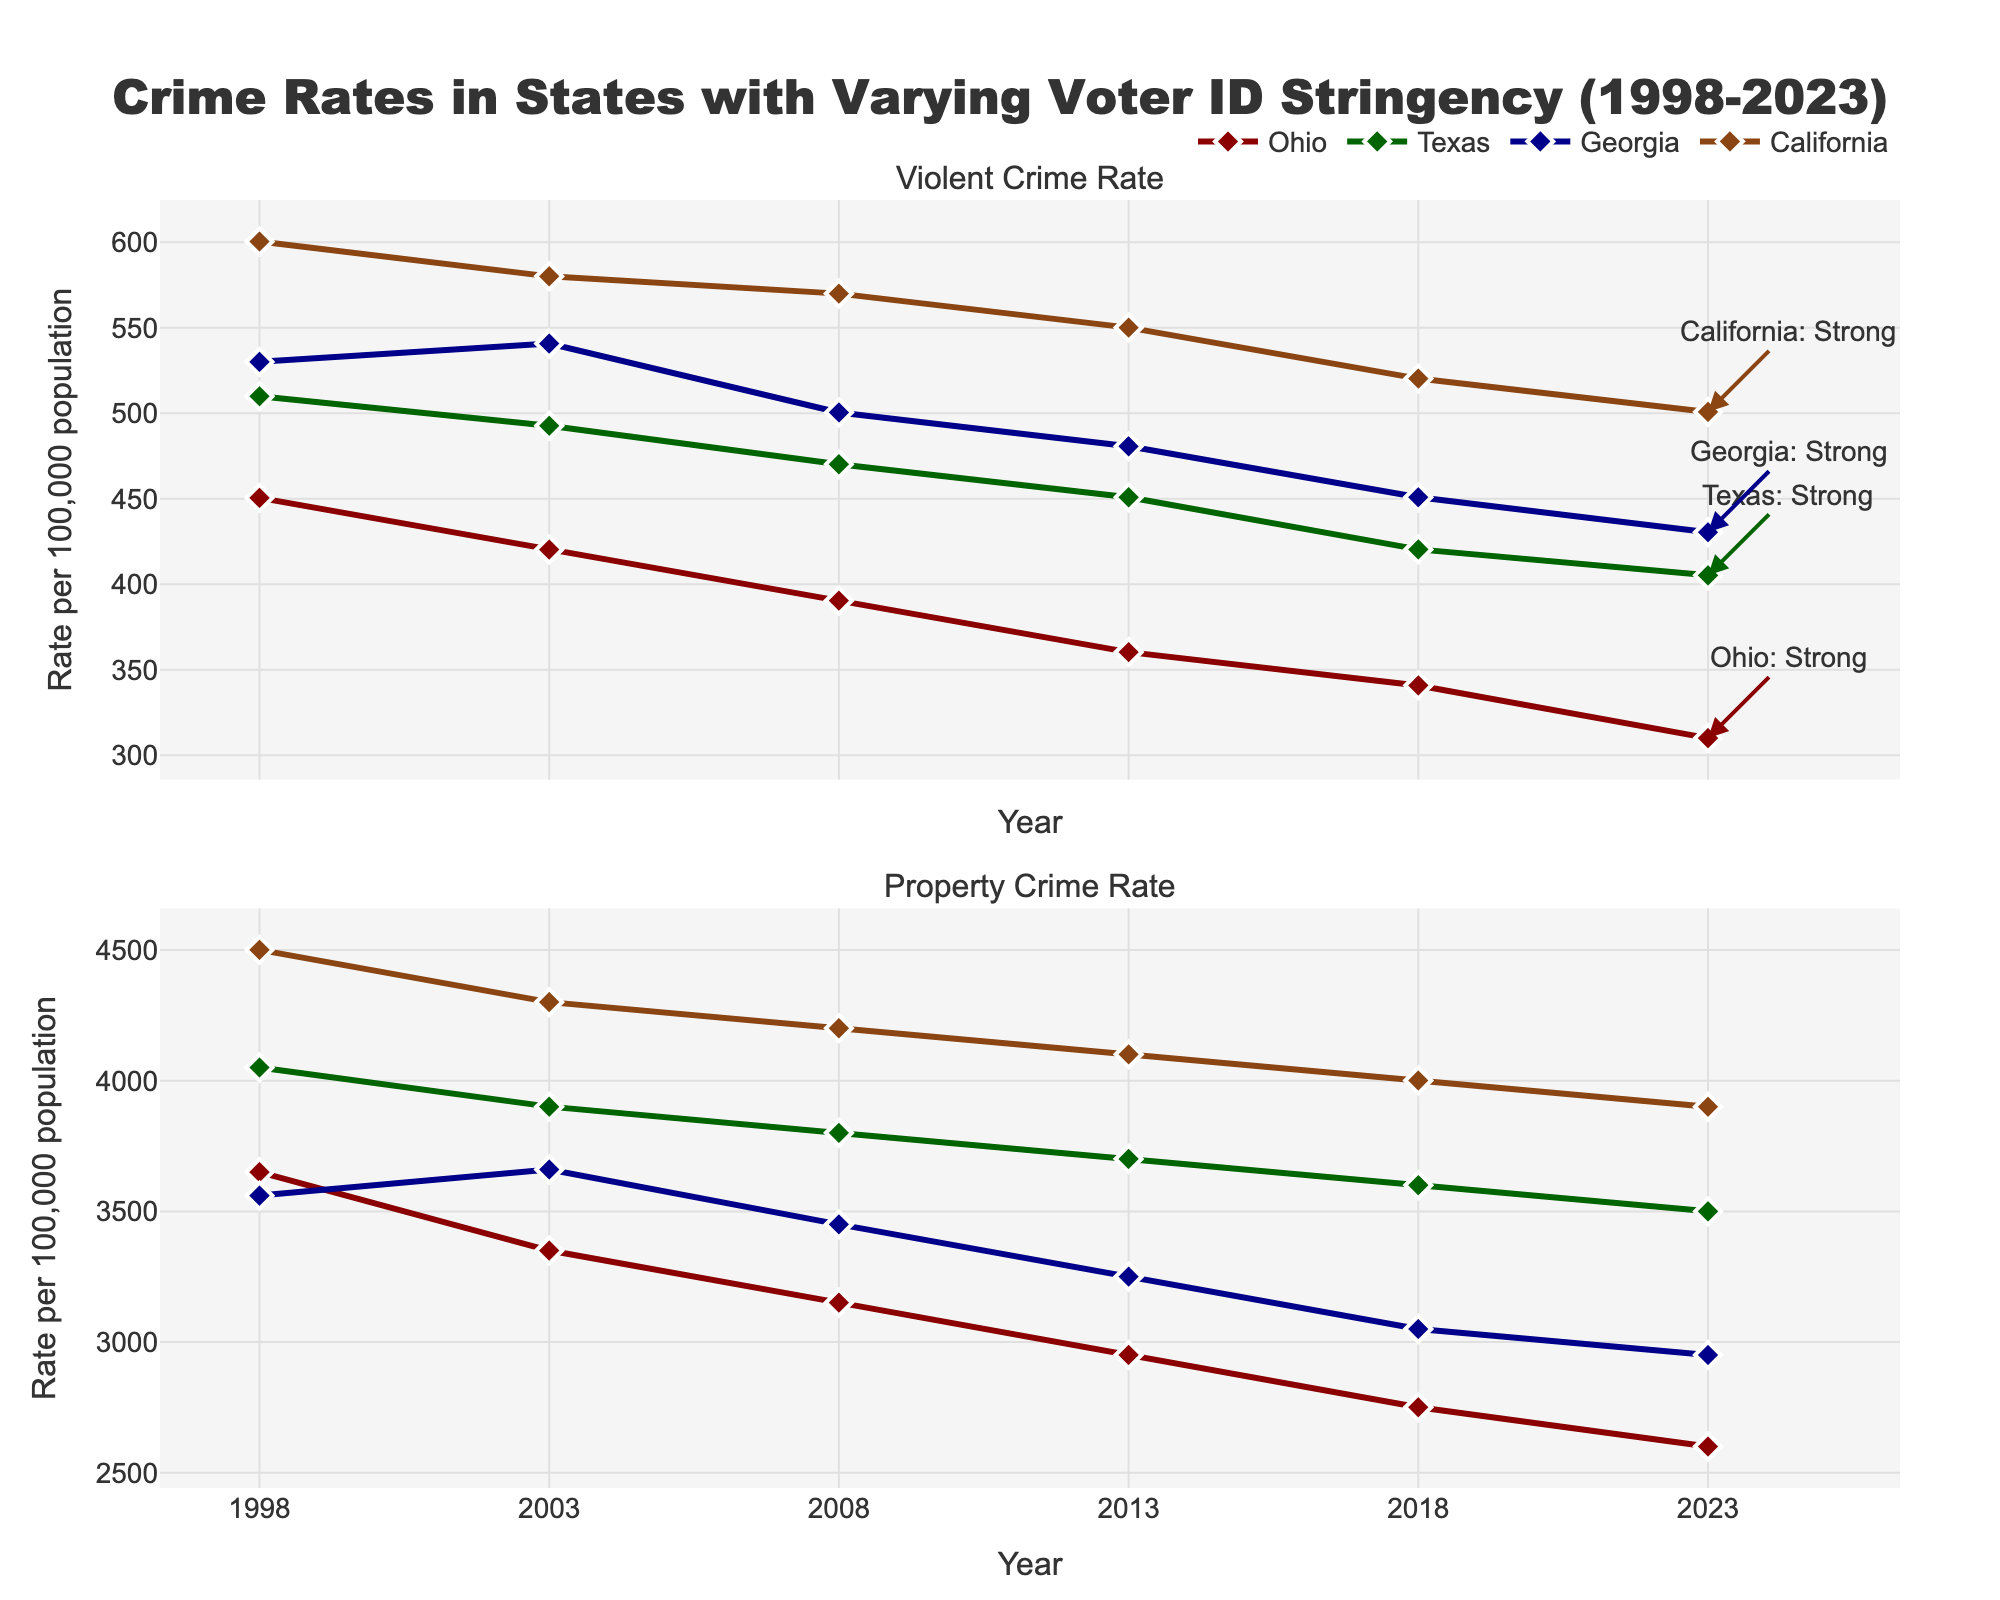What is the title of the figure? The title of a figure is typically found at the top and describes the content or the main topic of the visualization. In this case, it is "Crime Rates in States with Varying Voter ID Stringency (1998-2023)."
Answer: Crime Rates in States with Varying Voter ID Stringency (1998-2023) Which state shows the highest Violent Crime Rate in 2008? Look at the top subplot for 2008. Identify the highest point by checking the vertical position of the markers. The state corresponding to this peak is California, as its data point is the highest among other states.
Answer: California How has the Violent Crime Rate for Ohio changed from 1998 to 2023? Look at the line segment representing Ohio on the top subplot. Trace the data points for Ohio from 1998 to 2023: 450.5 in 1998 decreased to 310.0 in 2023, showing a decreasing trend.
Answer: Decreased In 2023, which state had the lowest Property Crime Rate and what is its value? Look at the bottom subplot for the data points in 2023. Identify the lowest point and check its corresponding state. Ohio has the lowest Property Crime Rate at 2600.3.
Answer: Ohio, 2600.3 Which state experienced the largest decrease in Violent Crime Rate between 1998 and 2023? Calculate the difference in Violent Crime Rates for each state between 1998 and 2023: Ohio (450.5 - 310.0 = 140.5), Texas (510.0 - 405.2 = 104.8), Georgia (530.1 - 430.4 = 99.7), and California (600.5 - 500.8 = 99.7). Ohio experienced the largest decrease.
Answer: Ohio What was the Property Crime Rate trend for Texas from 1998 to 2023? Observe Texas's line on the bottom subplot. Starting at 4050.3 in 1998, it decreased to 3500.2 by 2023. This indicates a decreasing trend over the years.
Answer: Decreasing Which year saw the highest Violent Crime Rate for California, and what was the value? Observe the top subplot and trace California's data points. The highest point is in 1998 with a Violent Crime Rate of 600.5.
Answer: 1998, 600.5 Compare Georgia’s Property Crime Rate in 1998 with its rate in 2023. Which year had a higher rate and by how much? Georgia's Property Crime Rate in 1998 is 3560.4, and in 2023 it is 2950.4. The rate in 1998 is higher by 610.0.
Answer: 1998, 610.0 higher Which state’s Violent Crime Rate was most stable (least change) from 1998 to 2023? Calculate the absolute changes in Violent Crime Rates between 1998 and 2023 for all states: Ohio (140.5), Texas (104.8), Georgia (99.7), and California (99.7). Both Georgia and California have the smallest change of 99.7, indicating they were the most stable.
Answer: Georgia, California How did the Voter ID Stringency for Ohio change from 1998 to 2023? Observing the annotations for Ohio in different years, it started with Weak in 1998 and became Strong by 2018 and stayed Strong till 2023.
Answer: From Weak to Strong 